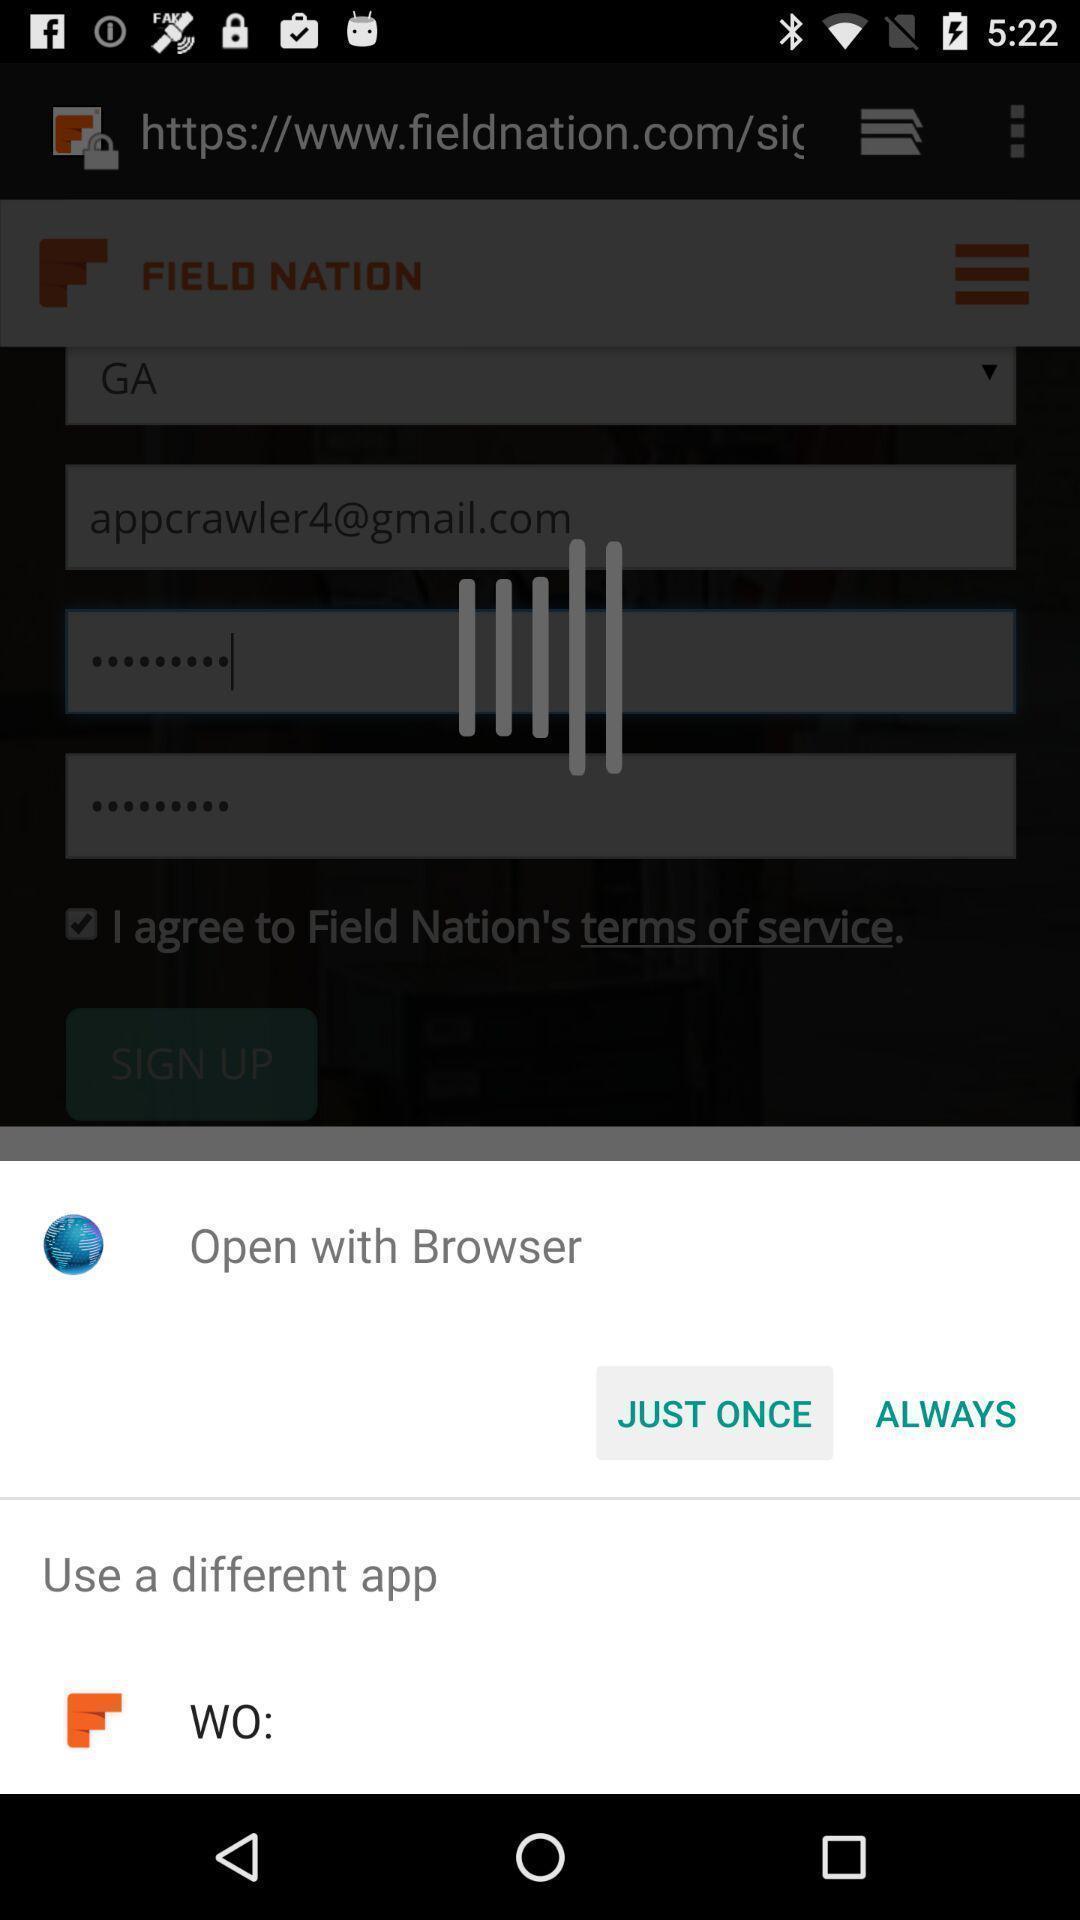Describe the visual elements of this screenshot. Pop up window asking to open with which app. 